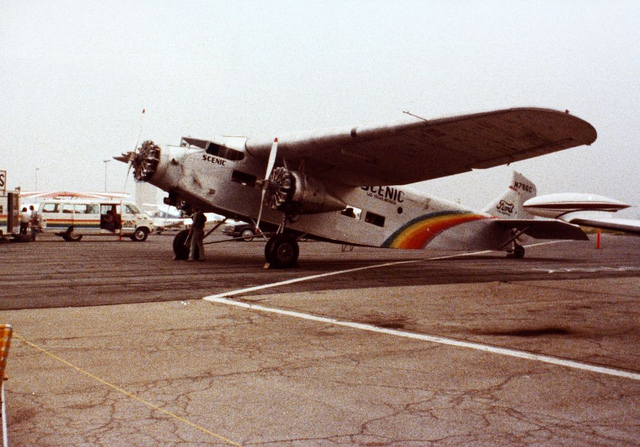What number is the plane? The number on the plane is 'N10609'. It is prominently displayed on the tail of the aircraft. 